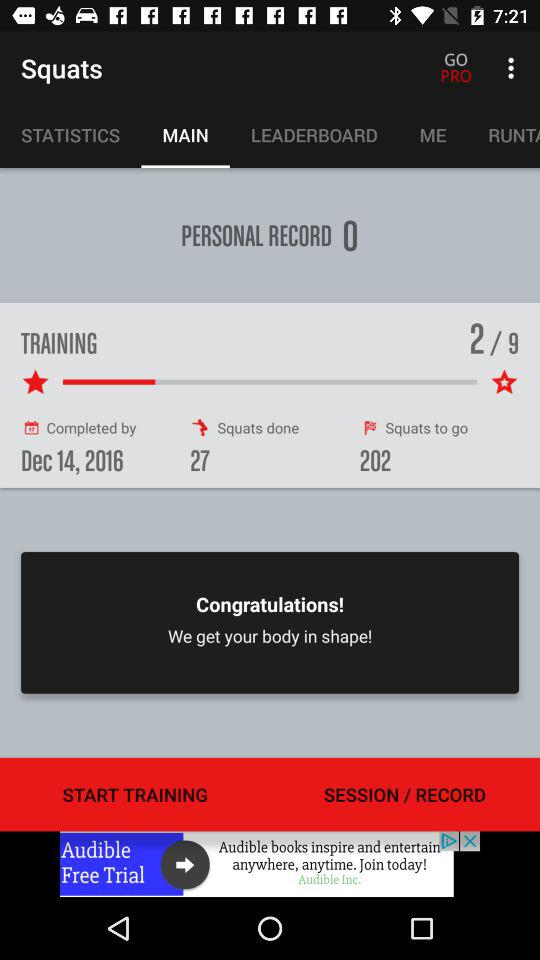Which option is selected in "Squats"? The selected option in "Squats" is "MAIN". 